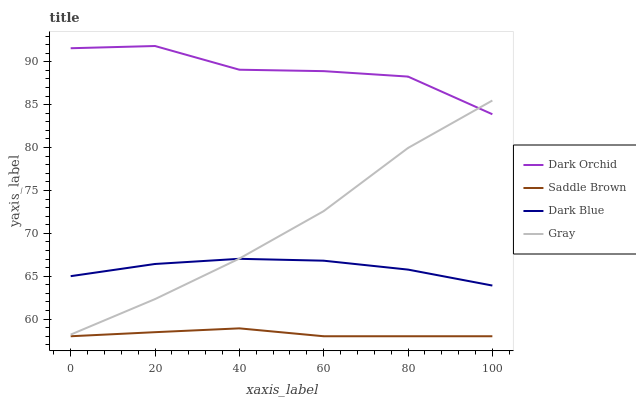Does Saddle Brown have the minimum area under the curve?
Answer yes or no. Yes. Does Dark Orchid have the maximum area under the curve?
Answer yes or no. Yes. Does Dark Orchid have the minimum area under the curve?
Answer yes or no. No. Does Saddle Brown have the maximum area under the curve?
Answer yes or no. No. Is Saddle Brown the smoothest?
Answer yes or no. Yes. Is Dark Orchid the roughest?
Answer yes or no. Yes. Is Dark Orchid the smoothest?
Answer yes or no. No. Is Saddle Brown the roughest?
Answer yes or no. No. Does Saddle Brown have the lowest value?
Answer yes or no. Yes. Does Dark Orchid have the lowest value?
Answer yes or no. No. Does Dark Orchid have the highest value?
Answer yes or no. Yes. Does Saddle Brown have the highest value?
Answer yes or no. No. Is Dark Blue less than Dark Orchid?
Answer yes or no. Yes. Is Dark Orchid greater than Saddle Brown?
Answer yes or no. Yes. Does Dark Blue intersect Gray?
Answer yes or no. Yes. Is Dark Blue less than Gray?
Answer yes or no. No. Is Dark Blue greater than Gray?
Answer yes or no. No. Does Dark Blue intersect Dark Orchid?
Answer yes or no. No. 